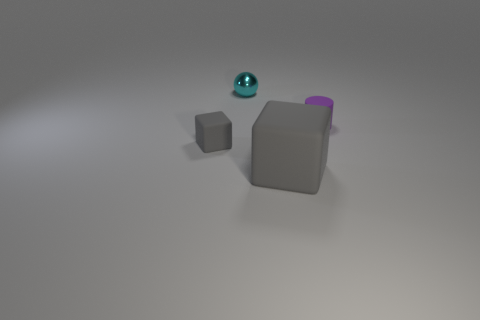There is a block to the right of the small shiny ball; what size is it?
Keep it short and to the point. Large. How many rubber things are on the right side of the gray matte object that is to the left of the big matte thing?
Give a very brief answer. 2. Is the shape of the small matte object that is left of the small cylinder the same as the big gray matte object right of the tiny gray rubber object?
Your answer should be very brief. Yes. What number of things are in front of the small matte cylinder and to the left of the big gray rubber block?
Keep it short and to the point. 1. Are there any tiny rubber cylinders of the same color as the large rubber thing?
Your response must be concise. No. There is a gray object that is the same size as the metal ball; what shape is it?
Provide a short and direct response. Cube. Are there any purple matte objects behind the small metal ball?
Offer a very short reply. No. Are the tiny object that is to the left of the small cyan metal sphere and the tiny object behind the purple rubber cylinder made of the same material?
Offer a very short reply. No. What number of gray objects are the same size as the cyan metallic sphere?
Your answer should be very brief. 1. There is another matte object that is the same color as the large object; what is its shape?
Provide a short and direct response. Cube. 